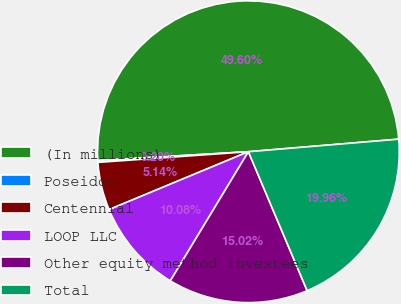Convert chart. <chart><loc_0><loc_0><loc_500><loc_500><pie_chart><fcel>(In millions)<fcel>Poseidon<fcel>Centennial<fcel>LOOP LLC<fcel>Other equity method investees<fcel>Total<nl><fcel>49.6%<fcel>0.2%<fcel>5.14%<fcel>10.08%<fcel>15.02%<fcel>19.96%<nl></chart> 